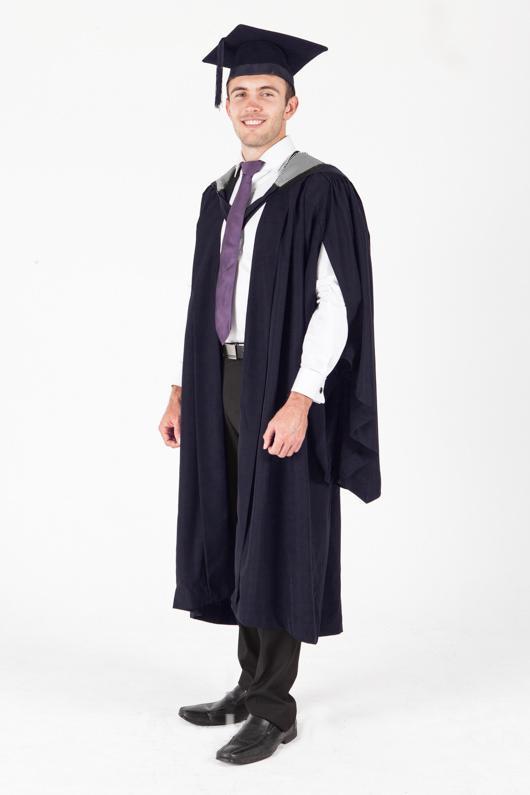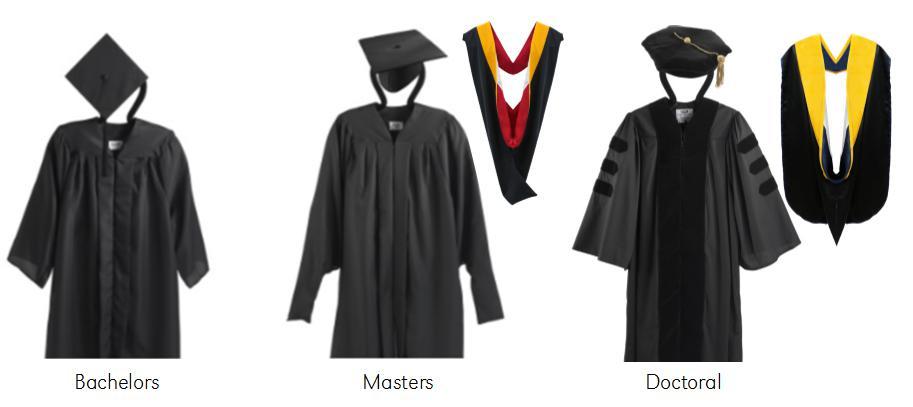The first image is the image on the left, the second image is the image on the right. Examine the images to the left and right. Is the description "There are more unworn clothes than people." accurate? Answer yes or no. Yes. The first image is the image on the left, the second image is the image on the right. Given the left and right images, does the statement "An image includes a young man standing at a leftward-turned angle, modeling a graduation robe and cap." hold true? Answer yes or no. Yes. 